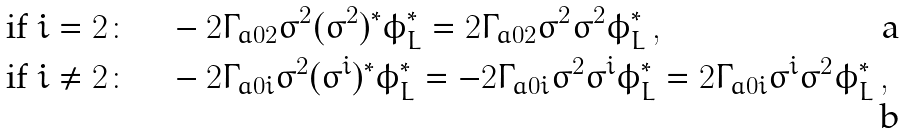<formula> <loc_0><loc_0><loc_500><loc_500>\text {if} \ i & = 2 \colon \quad - 2 \Gamma _ { a 0 2 } \sigma ^ { 2 } ( \sigma ^ { 2 } ) ^ { \ast } \phi ^ { \ast } _ { L } = 2 \Gamma _ { a 0 2 } \sigma ^ { 2 } \sigma ^ { 2 } \phi ^ { \ast } _ { L } \, , \\ \text {if} \ i & \neq 2 \colon \quad - 2 \Gamma _ { a 0 i } \sigma ^ { 2 } ( \sigma ^ { i } ) ^ { \ast } \phi ^ { \ast } _ { L } = - 2 \Gamma _ { a 0 i } \sigma ^ { 2 } \sigma ^ { i } \phi ^ { \ast } _ { L } = 2 \Gamma _ { a 0 i } \sigma ^ { i } \sigma ^ { 2 } \phi ^ { \ast } _ { L } \, ,</formula> 